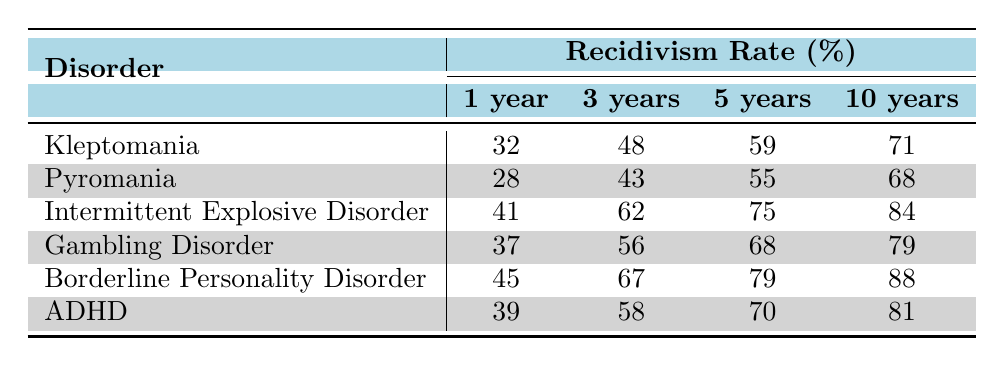What is the recidivism rate for Kleptomania after 5 years? The table shows that the recidivism rate for Kleptomania after 5 years is clearly stated as 59%.
Answer: 59% Which disorder has the highest recidivism rate after 10 years? By examining the 10-year column of the recidivism rates, Borderline Personality Disorder has the highest rate at 88%.
Answer: 88% What is the difference in the recidivism rate between Intermittent Explosive Disorder and Pyromania after 1 year? The recidivism rate for Intermittent Explosive Disorder after 1 year is 41%, while for Pyromania it is 28%. Subtracting these values gives 41 - 28 = 13.
Answer: 13 Is the recidivism rate for Gambling Disorder higher than that for ADHD after 3 years? The table indicates that the recidivism rate for Gambling Disorder after 3 years is 56% and for ADHD it is 58%. Thus, Gambling Disorder does not have a higher rate than ADHD.
Answer: No What is the average recidivism rate across all disorders after 1 year? To find the average for 1 year, sum the rates: 32 + 28 + 41 + 37 + 45 + 39 = 222. There are 6 disorders, so the average is 222 / 6 = 37.
Answer: 37 How does the recidivism rate for ADHD compare to that of Kleptomania after 3 years? ADHD has a recidivism rate of 58% after 3 years, while Kleptomania has a rate of 48%. ADHD has a higher rate, meaning that offenders with ADHD are more likely to recidivate than those with Kleptomania.
Answer: ADHD is higher If 100 individuals with Borderline Personality Disorder were studied, how many would you expect to recidivate after 5 years? The recidivism rate for Borderline Personality Disorder after 5 years is 79%. Therefore, if 100 individuals are studied, it is expected that 79 individuals would recidivate.
Answer: 79 What is the total recidivism rate among all disorders after 10 years? Adding the rates from the 10-year column gives: 71 + 68 + 84 + 79 + 88 + 81 = 471.
Answer: 471 Among the moderate recidivism rates (between 40% and 60%) after 1 year, how many disorders fall under this category? Examining the 1-year rates: Kleptomania (32%), Pyromania (28%), Intermittent Explosive Disorder (41%), and ADHD (39%) all fall between 40% and 60%. So, there are 3 disorders in that range.
Answer: 3 What is the least recidivism rate after 3 years among the disorders listed? The table shows that the lowest recidivism rate after 3 years is that of Pyromania at 43%.
Answer: 43 